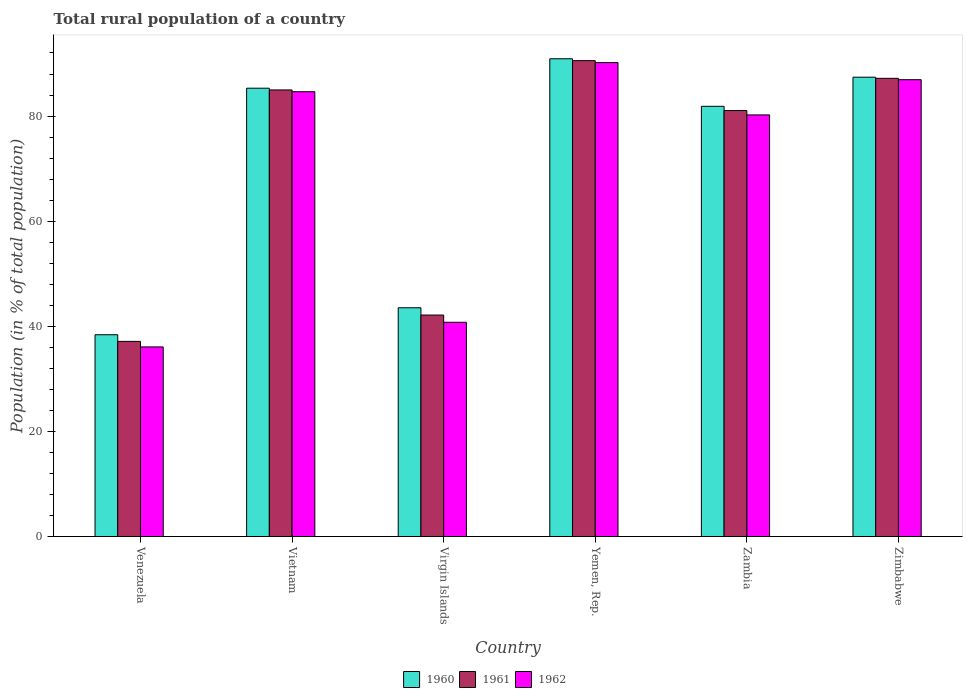Are the number of bars per tick equal to the number of legend labels?
Provide a succinct answer. Yes. Are the number of bars on each tick of the X-axis equal?
Keep it short and to the point. Yes. How many bars are there on the 5th tick from the right?
Keep it short and to the point. 3. What is the label of the 1st group of bars from the left?
Keep it short and to the point. Venezuela. In how many cases, is the number of bars for a given country not equal to the number of legend labels?
Give a very brief answer. 0. What is the rural population in 1962 in Zimbabwe?
Give a very brief answer. 86.92. Across all countries, what is the maximum rural population in 1962?
Provide a succinct answer. 90.17. Across all countries, what is the minimum rural population in 1961?
Offer a very short reply. 37.12. In which country was the rural population in 1961 maximum?
Ensure brevity in your answer.  Yemen, Rep. In which country was the rural population in 1961 minimum?
Ensure brevity in your answer.  Venezuela. What is the total rural population in 1962 in the graph?
Keep it short and to the point. 418.76. What is the difference between the rural population in 1961 in Vietnam and that in Virgin Islands?
Your answer should be very brief. 42.83. What is the difference between the rural population in 1961 in Zimbabwe and the rural population in 1960 in Vietnam?
Ensure brevity in your answer.  1.88. What is the average rural population in 1962 per country?
Ensure brevity in your answer.  69.79. What is the difference between the rural population of/in 1961 and rural population of/in 1960 in Zambia?
Your answer should be compact. -0.81. What is the ratio of the rural population in 1961 in Venezuela to that in Zambia?
Provide a succinct answer. 0.46. Is the rural population in 1960 in Vietnam less than that in Yemen, Rep.?
Give a very brief answer. Yes. What is the difference between the highest and the second highest rural population in 1960?
Your answer should be very brief. 5.6. What is the difference between the highest and the lowest rural population in 1961?
Make the answer very short. 53.42. In how many countries, is the rural population in 1960 greater than the average rural population in 1960 taken over all countries?
Provide a short and direct response. 4. What does the 2nd bar from the right in Zambia represents?
Your response must be concise. 1961. How many bars are there?
Offer a terse response. 18. What is the difference between two consecutive major ticks on the Y-axis?
Make the answer very short. 20. Are the values on the major ticks of Y-axis written in scientific E-notation?
Provide a succinct answer. No. Does the graph contain any zero values?
Ensure brevity in your answer.  No. How many legend labels are there?
Provide a short and direct response. 3. How are the legend labels stacked?
Offer a terse response. Horizontal. What is the title of the graph?
Your response must be concise. Total rural population of a country. Does "2010" appear as one of the legend labels in the graph?
Provide a short and direct response. No. What is the label or title of the Y-axis?
Your answer should be very brief. Population (in % of total population). What is the Population (in % of total population) of 1960 in Venezuela?
Keep it short and to the point. 38.39. What is the Population (in % of total population) of 1961 in Venezuela?
Offer a terse response. 37.12. What is the Population (in % of total population) in 1962 in Venezuela?
Make the answer very short. 36.07. What is the Population (in % of total population) of 1960 in Vietnam?
Your answer should be very brief. 85.3. What is the Population (in % of total population) in 1961 in Vietnam?
Offer a very short reply. 84.97. What is the Population (in % of total population) in 1962 in Vietnam?
Keep it short and to the point. 84.63. What is the Population (in % of total population) in 1960 in Virgin Islands?
Provide a short and direct response. 43.52. What is the Population (in % of total population) in 1961 in Virgin Islands?
Your answer should be very brief. 42.14. What is the Population (in % of total population) in 1962 in Virgin Islands?
Provide a short and direct response. 40.76. What is the Population (in % of total population) in 1960 in Yemen, Rep.?
Your answer should be compact. 90.9. What is the Population (in % of total population) in 1961 in Yemen, Rep.?
Provide a succinct answer. 90.54. What is the Population (in % of total population) in 1962 in Yemen, Rep.?
Offer a very short reply. 90.17. What is the Population (in % of total population) in 1960 in Zambia?
Offer a very short reply. 81.86. What is the Population (in % of total population) of 1961 in Zambia?
Make the answer very short. 81.05. What is the Population (in % of total population) of 1962 in Zambia?
Make the answer very short. 80.22. What is the Population (in % of total population) of 1960 in Zimbabwe?
Keep it short and to the point. 87.39. What is the Population (in % of total population) of 1961 in Zimbabwe?
Keep it short and to the point. 87.18. What is the Population (in % of total population) in 1962 in Zimbabwe?
Provide a short and direct response. 86.92. Across all countries, what is the maximum Population (in % of total population) in 1960?
Your answer should be compact. 90.9. Across all countries, what is the maximum Population (in % of total population) in 1961?
Offer a very short reply. 90.54. Across all countries, what is the maximum Population (in % of total population) in 1962?
Offer a terse response. 90.17. Across all countries, what is the minimum Population (in % of total population) in 1960?
Make the answer very short. 38.39. Across all countries, what is the minimum Population (in % of total population) of 1961?
Keep it short and to the point. 37.12. Across all countries, what is the minimum Population (in % of total population) of 1962?
Your answer should be compact. 36.07. What is the total Population (in % of total population) in 1960 in the graph?
Your response must be concise. 427.36. What is the total Population (in % of total population) of 1961 in the graph?
Your answer should be very brief. 423. What is the total Population (in % of total population) of 1962 in the graph?
Give a very brief answer. 418.76. What is the difference between the Population (in % of total population) of 1960 in Venezuela and that in Vietnam?
Your answer should be very brief. -46.91. What is the difference between the Population (in % of total population) of 1961 in Venezuela and that in Vietnam?
Keep it short and to the point. -47.84. What is the difference between the Population (in % of total population) of 1962 in Venezuela and that in Vietnam?
Your response must be concise. -48.56. What is the difference between the Population (in % of total population) of 1960 in Venezuela and that in Virgin Islands?
Offer a very short reply. -5.14. What is the difference between the Population (in % of total population) in 1961 in Venezuela and that in Virgin Islands?
Provide a succinct answer. -5.01. What is the difference between the Population (in % of total population) of 1962 in Venezuela and that in Virgin Islands?
Make the answer very short. -4.69. What is the difference between the Population (in % of total population) of 1960 in Venezuela and that in Yemen, Rep.?
Ensure brevity in your answer.  -52.51. What is the difference between the Population (in % of total population) in 1961 in Venezuela and that in Yemen, Rep.?
Offer a very short reply. -53.42. What is the difference between the Population (in % of total population) of 1962 in Venezuela and that in Yemen, Rep.?
Offer a terse response. -54.1. What is the difference between the Population (in % of total population) of 1960 in Venezuela and that in Zambia?
Your answer should be compact. -43.47. What is the difference between the Population (in % of total population) in 1961 in Venezuela and that in Zambia?
Give a very brief answer. -43.92. What is the difference between the Population (in % of total population) of 1962 in Venezuela and that in Zambia?
Your answer should be compact. -44.15. What is the difference between the Population (in % of total population) of 1960 in Venezuela and that in Zimbabwe?
Make the answer very short. -49.01. What is the difference between the Population (in % of total population) in 1961 in Venezuela and that in Zimbabwe?
Keep it short and to the point. -50.05. What is the difference between the Population (in % of total population) in 1962 in Venezuela and that in Zimbabwe?
Your response must be concise. -50.85. What is the difference between the Population (in % of total population) of 1960 in Vietnam and that in Virgin Islands?
Give a very brief answer. 41.78. What is the difference between the Population (in % of total population) of 1961 in Vietnam and that in Virgin Islands?
Your answer should be very brief. 42.83. What is the difference between the Population (in % of total population) in 1962 in Vietnam and that in Virgin Islands?
Your answer should be very brief. 43.87. What is the difference between the Population (in % of total population) of 1961 in Vietnam and that in Yemen, Rep.?
Ensure brevity in your answer.  -5.57. What is the difference between the Population (in % of total population) of 1962 in Vietnam and that in Yemen, Rep.?
Give a very brief answer. -5.54. What is the difference between the Population (in % of total population) in 1960 in Vietnam and that in Zambia?
Keep it short and to the point. 3.44. What is the difference between the Population (in % of total population) in 1961 in Vietnam and that in Zambia?
Keep it short and to the point. 3.92. What is the difference between the Population (in % of total population) in 1962 in Vietnam and that in Zambia?
Give a very brief answer. 4.42. What is the difference between the Population (in % of total population) in 1960 in Vietnam and that in Zimbabwe?
Offer a terse response. -2.09. What is the difference between the Population (in % of total population) of 1961 in Vietnam and that in Zimbabwe?
Provide a succinct answer. -2.21. What is the difference between the Population (in % of total population) of 1962 in Vietnam and that in Zimbabwe?
Your answer should be very brief. -2.29. What is the difference between the Population (in % of total population) in 1960 in Virgin Islands and that in Yemen, Rep.?
Provide a succinct answer. -47.38. What is the difference between the Population (in % of total population) of 1961 in Virgin Islands and that in Yemen, Rep.?
Your response must be concise. -48.41. What is the difference between the Population (in % of total population) of 1962 in Virgin Islands and that in Yemen, Rep.?
Keep it short and to the point. -49.41. What is the difference between the Population (in % of total population) of 1960 in Virgin Islands and that in Zambia?
Provide a short and direct response. -38.33. What is the difference between the Population (in % of total population) in 1961 in Virgin Islands and that in Zambia?
Keep it short and to the point. -38.91. What is the difference between the Population (in % of total population) of 1962 in Virgin Islands and that in Zambia?
Give a very brief answer. -39.46. What is the difference between the Population (in % of total population) in 1960 in Virgin Islands and that in Zimbabwe?
Your answer should be compact. -43.87. What is the difference between the Population (in % of total population) of 1961 in Virgin Islands and that in Zimbabwe?
Provide a succinct answer. -45.04. What is the difference between the Population (in % of total population) of 1962 in Virgin Islands and that in Zimbabwe?
Make the answer very short. -46.16. What is the difference between the Population (in % of total population) of 1960 in Yemen, Rep. and that in Zambia?
Your answer should be very brief. 9.04. What is the difference between the Population (in % of total population) of 1961 in Yemen, Rep. and that in Zambia?
Give a very brief answer. 9.49. What is the difference between the Population (in % of total population) in 1962 in Yemen, Rep. and that in Zambia?
Offer a very short reply. 9.95. What is the difference between the Population (in % of total population) in 1960 in Yemen, Rep. and that in Zimbabwe?
Your response must be concise. 3.51. What is the difference between the Population (in % of total population) of 1961 in Yemen, Rep. and that in Zimbabwe?
Ensure brevity in your answer.  3.36. What is the difference between the Population (in % of total population) in 1962 in Yemen, Rep. and that in Zimbabwe?
Make the answer very short. 3.25. What is the difference between the Population (in % of total population) of 1960 in Zambia and that in Zimbabwe?
Offer a terse response. -5.54. What is the difference between the Population (in % of total population) of 1961 in Zambia and that in Zimbabwe?
Keep it short and to the point. -6.13. What is the difference between the Population (in % of total population) in 1962 in Zambia and that in Zimbabwe?
Your response must be concise. -6.7. What is the difference between the Population (in % of total population) of 1960 in Venezuela and the Population (in % of total population) of 1961 in Vietnam?
Keep it short and to the point. -46.58. What is the difference between the Population (in % of total population) in 1960 in Venezuela and the Population (in % of total population) in 1962 in Vietnam?
Give a very brief answer. -46.24. What is the difference between the Population (in % of total population) in 1961 in Venezuela and the Population (in % of total population) in 1962 in Vietnam?
Your answer should be compact. -47.51. What is the difference between the Population (in % of total population) in 1960 in Venezuela and the Population (in % of total population) in 1961 in Virgin Islands?
Ensure brevity in your answer.  -3.75. What is the difference between the Population (in % of total population) of 1960 in Venezuela and the Population (in % of total population) of 1962 in Virgin Islands?
Provide a short and direct response. -2.37. What is the difference between the Population (in % of total population) of 1961 in Venezuela and the Population (in % of total population) of 1962 in Virgin Islands?
Provide a short and direct response. -3.63. What is the difference between the Population (in % of total population) in 1960 in Venezuela and the Population (in % of total population) in 1961 in Yemen, Rep.?
Make the answer very short. -52.15. What is the difference between the Population (in % of total population) in 1960 in Venezuela and the Population (in % of total population) in 1962 in Yemen, Rep.?
Your answer should be compact. -51.78. What is the difference between the Population (in % of total population) in 1961 in Venezuela and the Population (in % of total population) in 1962 in Yemen, Rep.?
Give a very brief answer. -53.04. What is the difference between the Population (in % of total population) of 1960 in Venezuela and the Population (in % of total population) of 1961 in Zambia?
Ensure brevity in your answer.  -42.66. What is the difference between the Population (in % of total population) of 1960 in Venezuela and the Population (in % of total population) of 1962 in Zambia?
Offer a terse response. -41.83. What is the difference between the Population (in % of total population) in 1961 in Venezuela and the Population (in % of total population) in 1962 in Zambia?
Ensure brevity in your answer.  -43.09. What is the difference between the Population (in % of total population) of 1960 in Venezuela and the Population (in % of total population) of 1961 in Zimbabwe?
Make the answer very short. -48.79. What is the difference between the Population (in % of total population) in 1960 in Venezuela and the Population (in % of total population) in 1962 in Zimbabwe?
Your answer should be compact. -48.53. What is the difference between the Population (in % of total population) in 1961 in Venezuela and the Population (in % of total population) in 1962 in Zimbabwe?
Your answer should be very brief. -49.79. What is the difference between the Population (in % of total population) in 1960 in Vietnam and the Population (in % of total population) in 1961 in Virgin Islands?
Keep it short and to the point. 43.16. What is the difference between the Population (in % of total population) in 1960 in Vietnam and the Population (in % of total population) in 1962 in Virgin Islands?
Provide a short and direct response. 44.54. What is the difference between the Population (in % of total population) in 1961 in Vietnam and the Population (in % of total population) in 1962 in Virgin Islands?
Your answer should be compact. 44.21. What is the difference between the Population (in % of total population) of 1960 in Vietnam and the Population (in % of total population) of 1961 in Yemen, Rep.?
Ensure brevity in your answer.  -5.24. What is the difference between the Population (in % of total population) in 1960 in Vietnam and the Population (in % of total population) in 1962 in Yemen, Rep.?
Your answer should be compact. -4.87. What is the difference between the Population (in % of total population) in 1961 in Vietnam and the Population (in % of total population) in 1962 in Yemen, Rep.?
Keep it short and to the point. -5.2. What is the difference between the Population (in % of total population) of 1960 in Vietnam and the Population (in % of total population) of 1961 in Zambia?
Keep it short and to the point. 4.25. What is the difference between the Population (in % of total population) of 1960 in Vietnam and the Population (in % of total population) of 1962 in Zambia?
Ensure brevity in your answer.  5.08. What is the difference between the Population (in % of total population) in 1961 in Vietnam and the Population (in % of total population) in 1962 in Zambia?
Your answer should be compact. 4.75. What is the difference between the Population (in % of total population) in 1960 in Vietnam and the Population (in % of total population) in 1961 in Zimbabwe?
Offer a very short reply. -1.88. What is the difference between the Population (in % of total population) of 1960 in Vietnam and the Population (in % of total population) of 1962 in Zimbabwe?
Offer a very short reply. -1.62. What is the difference between the Population (in % of total population) of 1961 in Vietnam and the Population (in % of total population) of 1962 in Zimbabwe?
Make the answer very short. -1.95. What is the difference between the Population (in % of total population) in 1960 in Virgin Islands and the Population (in % of total population) in 1961 in Yemen, Rep.?
Offer a terse response. -47.02. What is the difference between the Population (in % of total population) in 1960 in Virgin Islands and the Population (in % of total population) in 1962 in Yemen, Rep.?
Provide a succinct answer. -46.65. What is the difference between the Population (in % of total population) in 1961 in Virgin Islands and the Population (in % of total population) in 1962 in Yemen, Rep.?
Your response must be concise. -48.03. What is the difference between the Population (in % of total population) of 1960 in Virgin Islands and the Population (in % of total population) of 1961 in Zambia?
Offer a terse response. -37.53. What is the difference between the Population (in % of total population) in 1960 in Virgin Islands and the Population (in % of total population) in 1962 in Zambia?
Ensure brevity in your answer.  -36.69. What is the difference between the Population (in % of total population) of 1961 in Virgin Islands and the Population (in % of total population) of 1962 in Zambia?
Your response must be concise. -38.08. What is the difference between the Population (in % of total population) in 1960 in Virgin Islands and the Population (in % of total population) in 1961 in Zimbabwe?
Keep it short and to the point. -43.66. What is the difference between the Population (in % of total population) of 1960 in Virgin Islands and the Population (in % of total population) of 1962 in Zimbabwe?
Keep it short and to the point. -43.4. What is the difference between the Population (in % of total population) in 1961 in Virgin Islands and the Population (in % of total population) in 1962 in Zimbabwe?
Your response must be concise. -44.78. What is the difference between the Population (in % of total population) of 1960 in Yemen, Rep. and the Population (in % of total population) of 1961 in Zambia?
Offer a very short reply. 9.85. What is the difference between the Population (in % of total population) of 1960 in Yemen, Rep. and the Population (in % of total population) of 1962 in Zambia?
Make the answer very short. 10.69. What is the difference between the Population (in % of total population) in 1961 in Yemen, Rep. and the Population (in % of total population) in 1962 in Zambia?
Provide a succinct answer. 10.33. What is the difference between the Population (in % of total population) of 1960 in Yemen, Rep. and the Population (in % of total population) of 1961 in Zimbabwe?
Keep it short and to the point. 3.72. What is the difference between the Population (in % of total population) of 1960 in Yemen, Rep. and the Population (in % of total population) of 1962 in Zimbabwe?
Offer a terse response. 3.98. What is the difference between the Population (in % of total population) in 1961 in Yemen, Rep. and the Population (in % of total population) in 1962 in Zimbabwe?
Your response must be concise. 3.62. What is the difference between the Population (in % of total population) of 1960 in Zambia and the Population (in % of total population) of 1961 in Zimbabwe?
Make the answer very short. -5.32. What is the difference between the Population (in % of total population) in 1960 in Zambia and the Population (in % of total population) in 1962 in Zimbabwe?
Provide a succinct answer. -5.06. What is the difference between the Population (in % of total population) in 1961 in Zambia and the Population (in % of total population) in 1962 in Zimbabwe?
Provide a succinct answer. -5.87. What is the average Population (in % of total population) in 1960 per country?
Keep it short and to the point. 71.23. What is the average Population (in % of total population) in 1961 per country?
Your answer should be compact. 70.5. What is the average Population (in % of total population) in 1962 per country?
Your answer should be very brief. 69.79. What is the difference between the Population (in % of total population) in 1960 and Population (in % of total population) in 1961 in Venezuela?
Your answer should be very brief. 1.26. What is the difference between the Population (in % of total population) of 1960 and Population (in % of total population) of 1962 in Venezuela?
Provide a short and direct response. 2.32. What is the difference between the Population (in % of total population) of 1961 and Population (in % of total population) of 1962 in Venezuela?
Your response must be concise. 1.06. What is the difference between the Population (in % of total population) of 1960 and Population (in % of total population) of 1961 in Vietnam?
Make the answer very short. 0.33. What is the difference between the Population (in % of total population) of 1960 and Population (in % of total population) of 1962 in Vietnam?
Ensure brevity in your answer.  0.67. What is the difference between the Population (in % of total population) of 1961 and Population (in % of total population) of 1962 in Vietnam?
Ensure brevity in your answer.  0.34. What is the difference between the Population (in % of total population) in 1960 and Population (in % of total population) in 1961 in Virgin Islands?
Offer a very short reply. 1.39. What is the difference between the Population (in % of total population) of 1960 and Population (in % of total population) of 1962 in Virgin Islands?
Ensure brevity in your answer.  2.76. What is the difference between the Population (in % of total population) of 1961 and Population (in % of total population) of 1962 in Virgin Islands?
Keep it short and to the point. 1.38. What is the difference between the Population (in % of total population) of 1960 and Population (in % of total population) of 1961 in Yemen, Rep.?
Offer a very short reply. 0.36. What is the difference between the Population (in % of total population) in 1960 and Population (in % of total population) in 1962 in Yemen, Rep.?
Provide a succinct answer. 0.73. What is the difference between the Population (in % of total population) in 1961 and Population (in % of total population) in 1962 in Yemen, Rep.?
Your answer should be compact. 0.37. What is the difference between the Population (in % of total population) of 1960 and Population (in % of total population) of 1961 in Zambia?
Give a very brief answer. 0.81. What is the difference between the Population (in % of total population) in 1960 and Population (in % of total population) in 1962 in Zambia?
Offer a very short reply. 1.64. What is the difference between the Population (in % of total population) in 1961 and Population (in % of total population) in 1962 in Zambia?
Offer a very short reply. 0.83. What is the difference between the Population (in % of total population) of 1960 and Population (in % of total population) of 1961 in Zimbabwe?
Offer a terse response. 0.21. What is the difference between the Population (in % of total population) in 1960 and Population (in % of total population) in 1962 in Zimbabwe?
Offer a very short reply. 0.47. What is the difference between the Population (in % of total population) in 1961 and Population (in % of total population) in 1962 in Zimbabwe?
Ensure brevity in your answer.  0.26. What is the ratio of the Population (in % of total population) in 1960 in Venezuela to that in Vietnam?
Keep it short and to the point. 0.45. What is the ratio of the Population (in % of total population) in 1961 in Venezuela to that in Vietnam?
Offer a terse response. 0.44. What is the ratio of the Population (in % of total population) of 1962 in Venezuela to that in Vietnam?
Your response must be concise. 0.43. What is the ratio of the Population (in % of total population) of 1960 in Venezuela to that in Virgin Islands?
Provide a succinct answer. 0.88. What is the ratio of the Population (in % of total population) in 1961 in Venezuela to that in Virgin Islands?
Provide a short and direct response. 0.88. What is the ratio of the Population (in % of total population) in 1962 in Venezuela to that in Virgin Islands?
Keep it short and to the point. 0.88. What is the ratio of the Population (in % of total population) of 1960 in Venezuela to that in Yemen, Rep.?
Offer a very short reply. 0.42. What is the ratio of the Population (in % of total population) of 1961 in Venezuela to that in Yemen, Rep.?
Offer a terse response. 0.41. What is the ratio of the Population (in % of total population) of 1962 in Venezuela to that in Yemen, Rep.?
Your answer should be compact. 0.4. What is the ratio of the Population (in % of total population) of 1960 in Venezuela to that in Zambia?
Give a very brief answer. 0.47. What is the ratio of the Population (in % of total population) in 1961 in Venezuela to that in Zambia?
Give a very brief answer. 0.46. What is the ratio of the Population (in % of total population) in 1962 in Venezuela to that in Zambia?
Offer a terse response. 0.45. What is the ratio of the Population (in % of total population) in 1960 in Venezuela to that in Zimbabwe?
Your answer should be very brief. 0.44. What is the ratio of the Population (in % of total population) in 1961 in Venezuela to that in Zimbabwe?
Your answer should be very brief. 0.43. What is the ratio of the Population (in % of total population) in 1962 in Venezuela to that in Zimbabwe?
Ensure brevity in your answer.  0.41. What is the ratio of the Population (in % of total population) in 1960 in Vietnam to that in Virgin Islands?
Your answer should be very brief. 1.96. What is the ratio of the Population (in % of total population) in 1961 in Vietnam to that in Virgin Islands?
Provide a succinct answer. 2.02. What is the ratio of the Population (in % of total population) in 1962 in Vietnam to that in Virgin Islands?
Offer a very short reply. 2.08. What is the ratio of the Population (in % of total population) in 1960 in Vietnam to that in Yemen, Rep.?
Your answer should be compact. 0.94. What is the ratio of the Population (in % of total population) in 1961 in Vietnam to that in Yemen, Rep.?
Make the answer very short. 0.94. What is the ratio of the Population (in % of total population) in 1962 in Vietnam to that in Yemen, Rep.?
Keep it short and to the point. 0.94. What is the ratio of the Population (in % of total population) of 1960 in Vietnam to that in Zambia?
Your response must be concise. 1.04. What is the ratio of the Population (in % of total population) of 1961 in Vietnam to that in Zambia?
Your response must be concise. 1.05. What is the ratio of the Population (in % of total population) in 1962 in Vietnam to that in Zambia?
Give a very brief answer. 1.06. What is the ratio of the Population (in % of total population) in 1960 in Vietnam to that in Zimbabwe?
Provide a succinct answer. 0.98. What is the ratio of the Population (in % of total population) of 1961 in Vietnam to that in Zimbabwe?
Your response must be concise. 0.97. What is the ratio of the Population (in % of total population) in 1962 in Vietnam to that in Zimbabwe?
Offer a terse response. 0.97. What is the ratio of the Population (in % of total population) in 1960 in Virgin Islands to that in Yemen, Rep.?
Your response must be concise. 0.48. What is the ratio of the Population (in % of total population) in 1961 in Virgin Islands to that in Yemen, Rep.?
Offer a terse response. 0.47. What is the ratio of the Population (in % of total population) in 1962 in Virgin Islands to that in Yemen, Rep.?
Give a very brief answer. 0.45. What is the ratio of the Population (in % of total population) of 1960 in Virgin Islands to that in Zambia?
Your response must be concise. 0.53. What is the ratio of the Population (in % of total population) of 1961 in Virgin Islands to that in Zambia?
Offer a terse response. 0.52. What is the ratio of the Population (in % of total population) of 1962 in Virgin Islands to that in Zambia?
Provide a short and direct response. 0.51. What is the ratio of the Population (in % of total population) in 1960 in Virgin Islands to that in Zimbabwe?
Offer a terse response. 0.5. What is the ratio of the Population (in % of total population) of 1961 in Virgin Islands to that in Zimbabwe?
Offer a terse response. 0.48. What is the ratio of the Population (in % of total population) of 1962 in Virgin Islands to that in Zimbabwe?
Offer a very short reply. 0.47. What is the ratio of the Population (in % of total population) of 1960 in Yemen, Rep. to that in Zambia?
Provide a short and direct response. 1.11. What is the ratio of the Population (in % of total population) of 1961 in Yemen, Rep. to that in Zambia?
Ensure brevity in your answer.  1.12. What is the ratio of the Population (in % of total population) in 1962 in Yemen, Rep. to that in Zambia?
Make the answer very short. 1.12. What is the ratio of the Population (in % of total population) in 1960 in Yemen, Rep. to that in Zimbabwe?
Keep it short and to the point. 1.04. What is the ratio of the Population (in % of total population) in 1961 in Yemen, Rep. to that in Zimbabwe?
Give a very brief answer. 1.04. What is the ratio of the Population (in % of total population) in 1962 in Yemen, Rep. to that in Zimbabwe?
Give a very brief answer. 1.04. What is the ratio of the Population (in % of total population) in 1960 in Zambia to that in Zimbabwe?
Keep it short and to the point. 0.94. What is the ratio of the Population (in % of total population) of 1961 in Zambia to that in Zimbabwe?
Your answer should be very brief. 0.93. What is the ratio of the Population (in % of total population) of 1962 in Zambia to that in Zimbabwe?
Offer a terse response. 0.92. What is the difference between the highest and the second highest Population (in % of total population) of 1960?
Offer a very short reply. 3.51. What is the difference between the highest and the second highest Population (in % of total population) of 1961?
Your answer should be compact. 3.36. What is the difference between the highest and the second highest Population (in % of total population) in 1962?
Offer a very short reply. 3.25. What is the difference between the highest and the lowest Population (in % of total population) of 1960?
Keep it short and to the point. 52.51. What is the difference between the highest and the lowest Population (in % of total population) of 1961?
Your answer should be compact. 53.42. What is the difference between the highest and the lowest Population (in % of total population) in 1962?
Offer a very short reply. 54.1. 